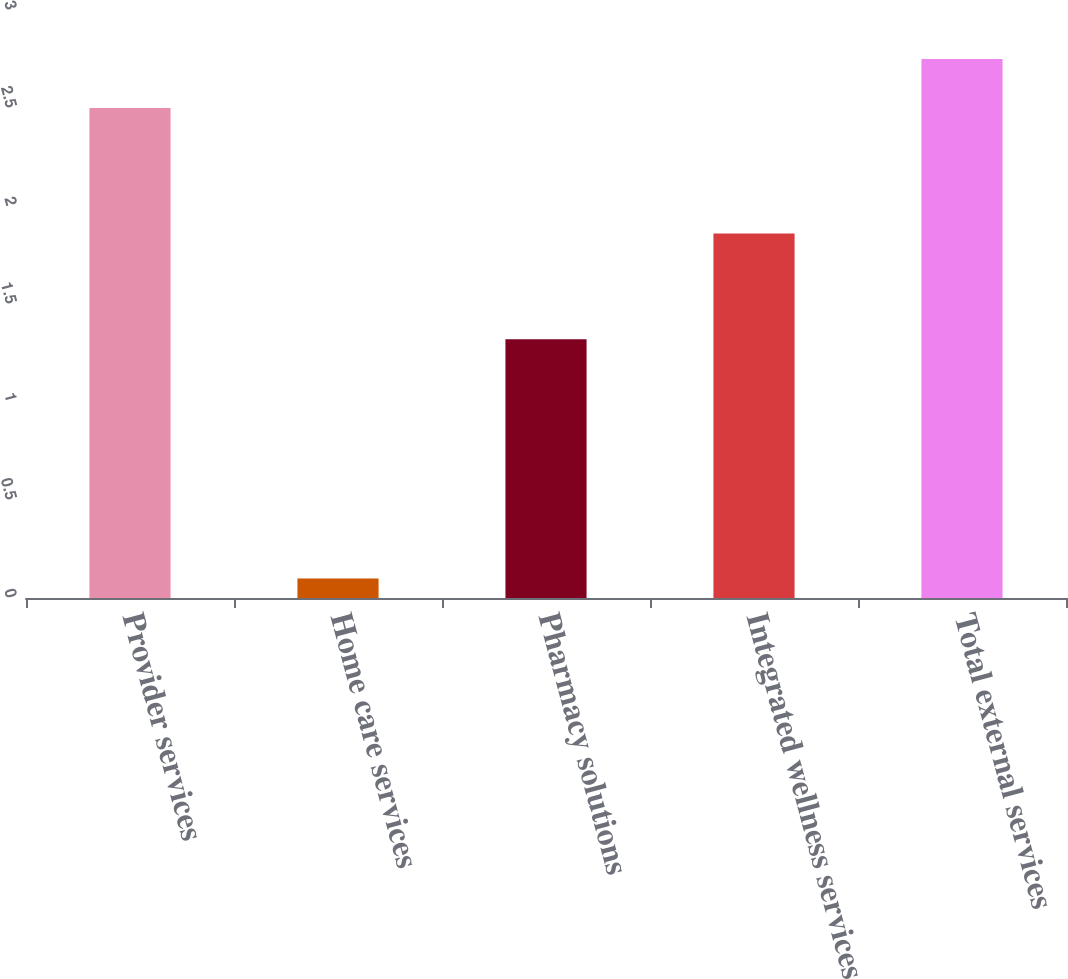Convert chart to OTSL. <chart><loc_0><loc_0><loc_500><loc_500><bar_chart><fcel>Provider services<fcel>Home care services<fcel>Pharmacy solutions<fcel>Integrated wellness services<fcel>Total external services<nl><fcel>2.5<fcel>0.1<fcel>1.32<fcel>1.86<fcel>2.75<nl></chart> 